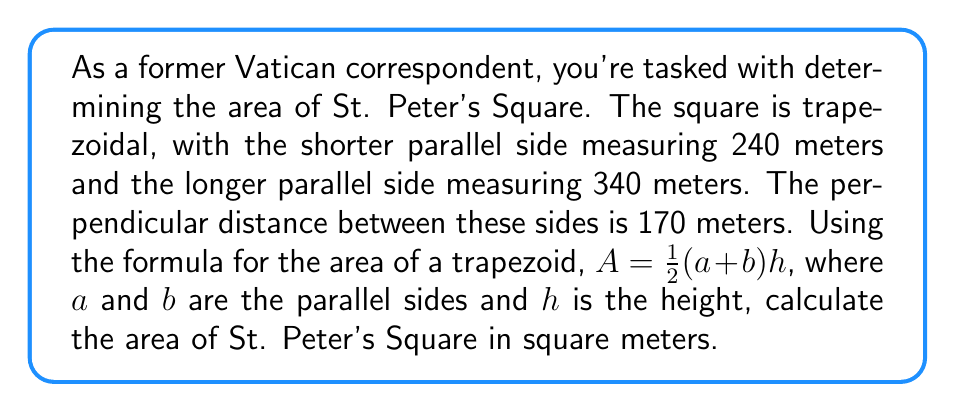Provide a solution to this math problem. Let's approach this step-by-step:

1. Identify the given measurements:
   - Shorter parallel side (a) = 240 meters
   - Longer parallel side (b) = 340 meters
   - Height (h) = 170 meters

2. Recall the formula for the area of a trapezoid:
   $A = \frac{1}{2}(a+b)h$

3. Substitute the values into the formula:
   $A = \frac{1}{2}(240 + 340) \times 170$

4. Simplify inside the parentheses:
   $A = \frac{1}{2}(580) \times 170$

5. Multiply:
   $A = 290 \times 170$

6. Calculate the final result:
   $A = 49,300$

Therefore, the area of St. Peter's Square is 49,300 square meters.
Answer: 49,300 m² 